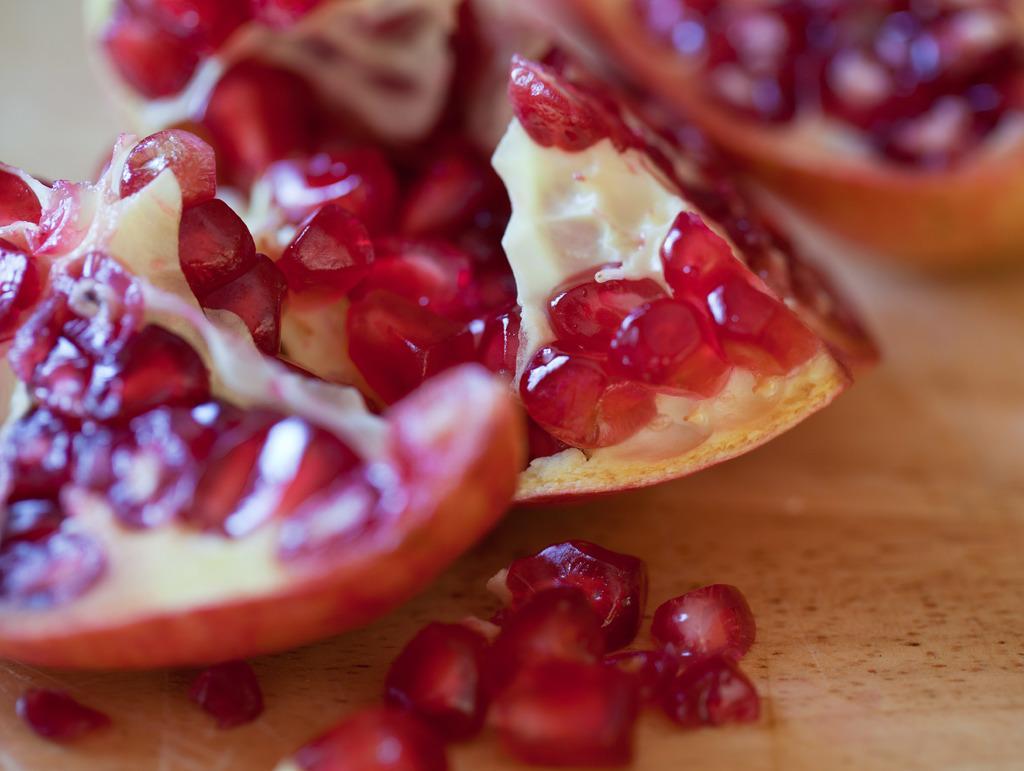Describe this image in one or two sentences. This picture contains pomegranate and its seeds placed on the table. 